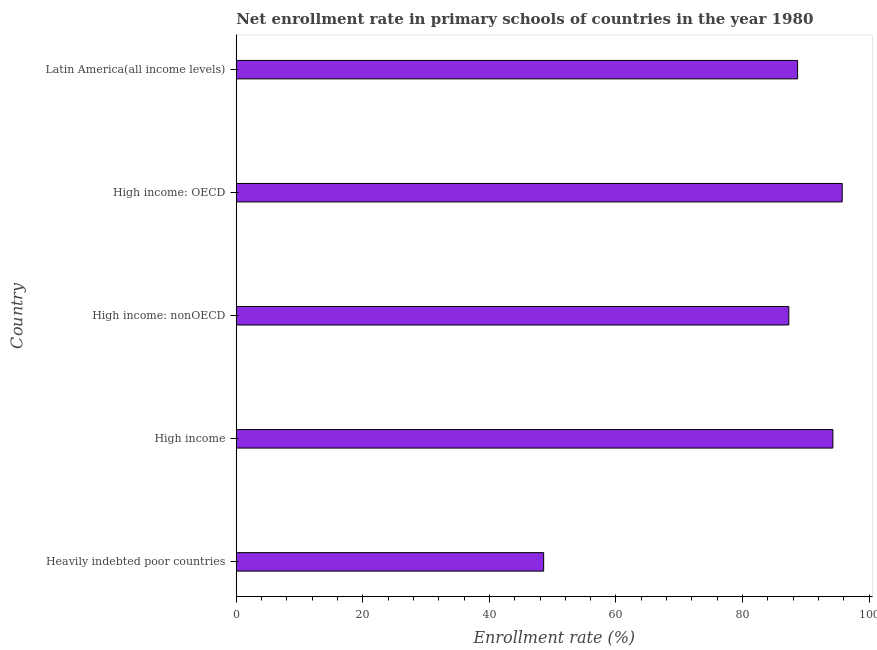Does the graph contain any zero values?
Ensure brevity in your answer.  No. Does the graph contain grids?
Make the answer very short. No. What is the title of the graph?
Your response must be concise. Net enrollment rate in primary schools of countries in the year 1980. What is the label or title of the X-axis?
Make the answer very short. Enrollment rate (%). What is the label or title of the Y-axis?
Offer a terse response. Country. What is the net enrollment rate in primary schools in High income: OECD?
Ensure brevity in your answer.  95.74. Across all countries, what is the maximum net enrollment rate in primary schools?
Ensure brevity in your answer.  95.74. Across all countries, what is the minimum net enrollment rate in primary schools?
Offer a very short reply. 48.57. In which country was the net enrollment rate in primary schools maximum?
Give a very brief answer. High income: OECD. In which country was the net enrollment rate in primary schools minimum?
Make the answer very short. Heavily indebted poor countries. What is the sum of the net enrollment rate in primary schools?
Provide a short and direct response. 414.6. What is the difference between the net enrollment rate in primary schools in Heavily indebted poor countries and High income: nonOECD?
Ensure brevity in your answer.  -38.74. What is the average net enrollment rate in primary schools per country?
Your response must be concise. 82.92. What is the median net enrollment rate in primary schools?
Your answer should be compact. 88.7. What is the ratio of the net enrollment rate in primary schools in High income to that in Latin America(all income levels)?
Provide a succinct answer. 1.06. What is the difference between the highest and the second highest net enrollment rate in primary schools?
Provide a short and direct response. 1.47. Is the sum of the net enrollment rate in primary schools in Heavily indebted poor countries and High income greater than the maximum net enrollment rate in primary schools across all countries?
Ensure brevity in your answer.  Yes. What is the difference between the highest and the lowest net enrollment rate in primary schools?
Provide a succinct answer. 47.17. How many bars are there?
Give a very brief answer. 5. Are all the bars in the graph horizontal?
Offer a very short reply. Yes. How many countries are there in the graph?
Provide a short and direct response. 5. What is the difference between two consecutive major ticks on the X-axis?
Provide a short and direct response. 20. What is the Enrollment rate (%) of Heavily indebted poor countries?
Your answer should be compact. 48.57. What is the Enrollment rate (%) of High income?
Make the answer very short. 94.27. What is the Enrollment rate (%) of High income: nonOECD?
Ensure brevity in your answer.  87.31. What is the Enrollment rate (%) in High income: OECD?
Give a very brief answer. 95.74. What is the Enrollment rate (%) of Latin America(all income levels)?
Your response must be concise. 88.7. What is the difference between the Enrollment rate (%) in Heavily indebted poor countries and High income?
Offer a very short reply. -45.7. What is the difference between the Enrollment rate (%) in Heavily indebted poor countries and High income: nonOECD?
Keep it short and to the point. -38.74. What is the difference between the Enrollment rate (%) in Heavily indebted poor countries and High income: OECD?
Make the answer very short. -47.17. What is the difference between the Enrollment rate (%) in Heavily indebted poor countries and Latin America(all income levels)?
Give a very brief answer. -40.13. What is the difference between the Enrollment rate (%) in High income and High income: nonOECD?
Keep it short and to the point. 6.96. What is the difference between the Enrollment rate (%) in High income and High income: OECD?
Offer a terse response. -1.47. What is the difference between the Enrollment rate (%) in High income and Latin America(all income levels)?
Ensure brevity in your answer.  5.58. What is the difference between the Enrollment rate (%) in High income: nonOECD and High income: OECD?
Your response must be concise. -8.43. What is the difference between the Enrollment rate (%) in High income: nonOECD and Latin America(all income levels)?
Provide a short and direct response. -1.39. What is the difference between the Enrollment rate (%) in High income: OECD and Latin America(all income levels)?
Your response must be concise. 7.05. What is the ratio of the Enrollment rate (%) in Heavily indebted poor countries to that in High income?
Provide a short and direct response. 0.52. What is the ratio of the Enrollment rate (%) in Heavily indebted poor countries to that in High income: nonOECD?
Your answer should be compact. 0.56. What is the ratio of the Enrollment rate (%) in Heavily indebted poor countries to that in High income: OECD?
Your answer should be very brief. 0.51. What is the ratio of the Enrollment rate (%) in Heavily indebted poor countries to that in Latin America(all income levels)?
Give a very brief answer. 0.55. What is the ratio of the Enrollment rate (%) in High income to that in High income: OECD?
Your response must be concise. 0.98. What is the ratio of the Enrollment rate (%) in High income to that in Latin America(all income levels)?
Give a very brief answer. 1.06. What is the ratio of the Enrollment rate (%) in High income: nonOECD to that in High income: OECD?
Ensure brevity in your answer.  0.91. What is the ratio of the Enrollment rate (%) in High income: OECD to that in Latin America(all income levels)?
Keep it short and to the point. 1.08. 